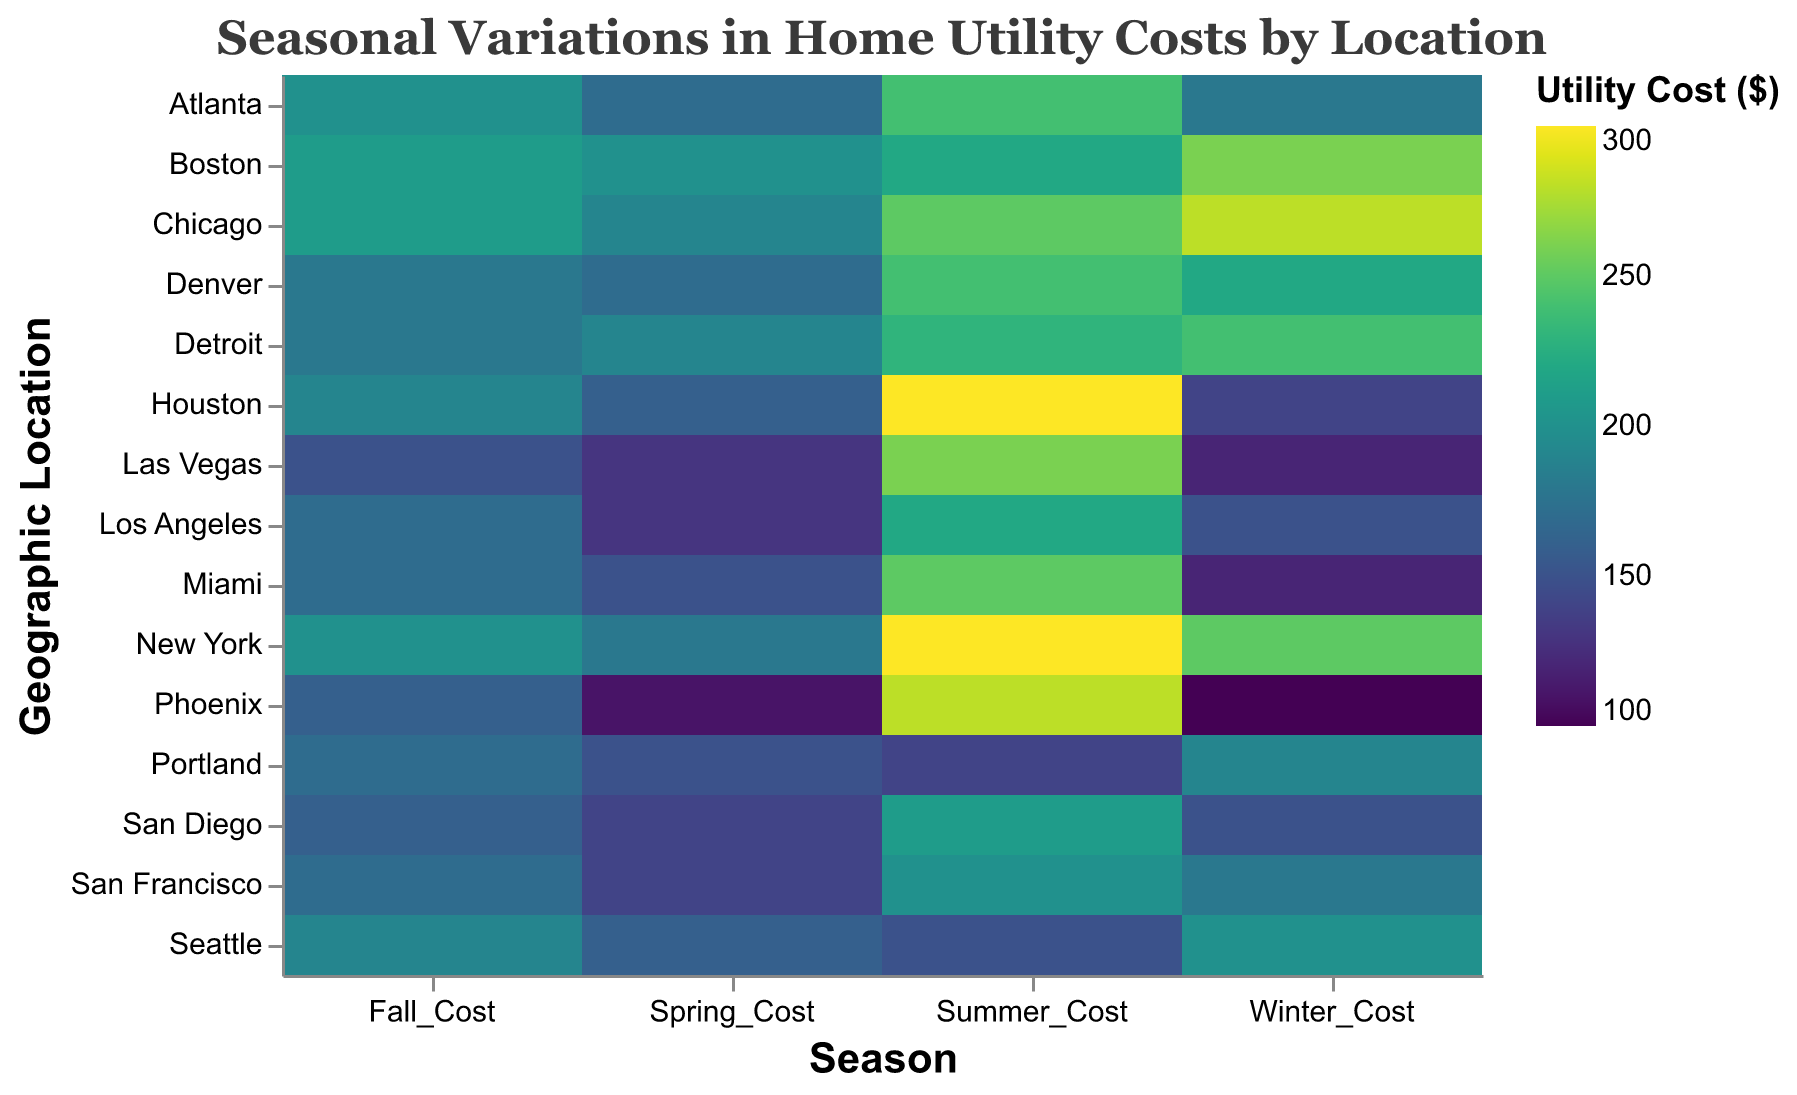What is the title of the heatmap? The title of the heatmap is located at the top of the figure and provides an overall description of what the heatmap is about.
Answer: Seasonal Variations in Home Utility Costs by Location Which geographic location has the highest utility cost in summer? Look at the summer column and identify the geographic location with the darkest color, which represents the highest cost. According to the tooltip or the intensity of the color, we see that New York and Houston have the highest summer utility cost of $300.
Answer: New York, Houston Which season has the most variation in utility costs across different locations? Assess the spread and range of colors in each season column. The season with the widest range of colors (from light to dark) indicates the greatest variation.
Answer: Summer What is the average utility cost in Los Angeles across all seasons? To find the average, sum the seasonal costs for Los Angeles and divide by the number of seasons (4). Here, (150 + 130 + 220 + 170) / 4 = 670 / 4 = 167.5.
Answer: 167.5 How do the winter utility costs compare between Boston and Phoenix? Identify the winter costs for both Boston and Phoenix from the y-axis and compare the two values. Boston has a cost of $260 and Phoenix has a cost of $100, indicating Boston's cost is significantly higher.
Answer: Boston's winter cost ($260) is higher than Phoenix's ($100) Which geographic location has the lowest utility cost in fall? Look at the fall column and locate the lightest color which indicates the lowest cost. According to the tooltip or the color intensity, Las Vegas has the fall utility cost of $150.
Answer: Las Vegas Is there a geographic location where the utility cost remains relatively stable across all seasons? Look for a row in the heatmap where the colors are relatively similar or show minimal variation across all seasons. Seattle and San Francisco both show relatively stable costs with minimal variation in color intensity.
Answer: Seattle, San Francisco Calculate the total yearly utility cost for Miami. sum the seasonal costs for Miami (120 + 150 + 250 + 170). The total is 690.
Answer: 690 How does the utility cost in New York in winter compare to spring? Look at the winter and spring costs for New York from the y-axis and compare the two values. Winter has a cost of $250 and spring has a cost of $180, so winter costs are higher.
Answer: Winter ($250) is higher than Spring ($180) Which geographic location has the highest overall utility cost when considering all seasons together? Sum the costs for each season for each location and compare. New York has the highest total with (250 + 180 + 300 + 200) = 930.
Answer: New York 